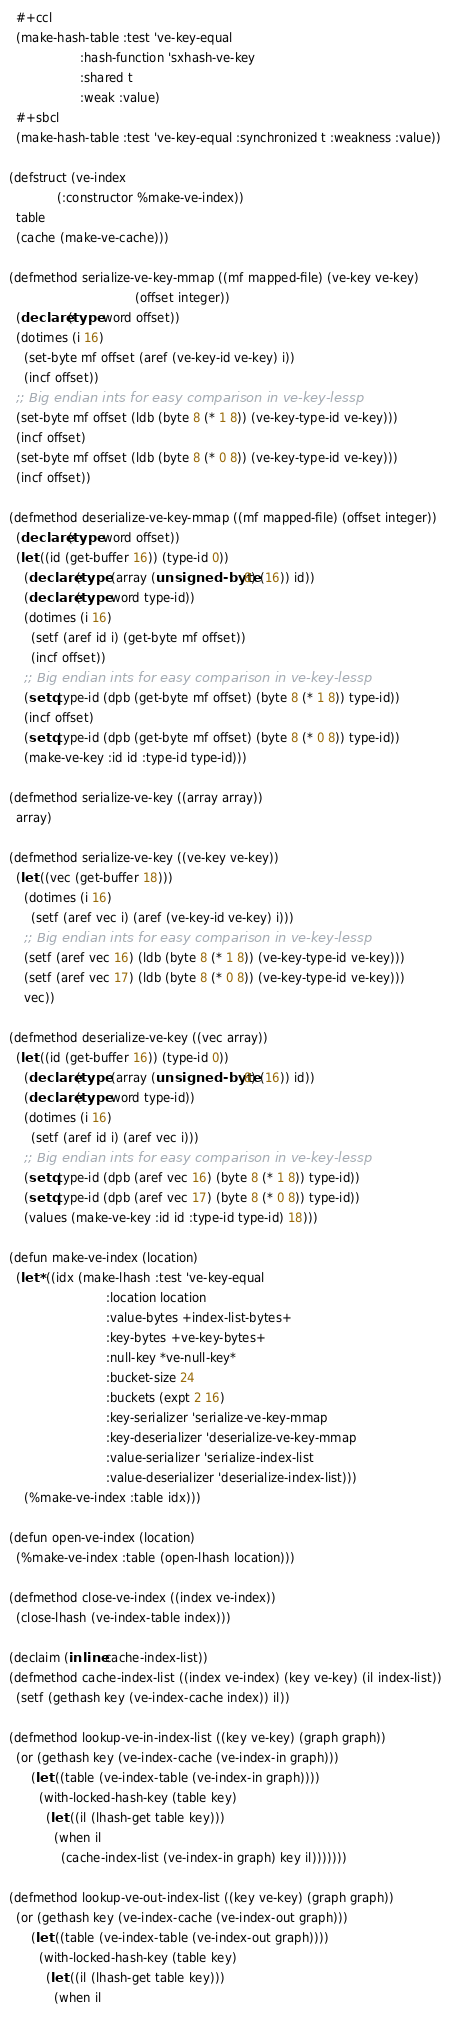<code> <loc_0><loc_0><loc_500><loc_500><_Lisp_>  #+ccl
  (make-hash-table :test 've-key-equal
                   :hash-function 'sxhash-ve-key
                   :shared t
                   :weak :value)
  #+sbcl
  (make-hash-table :test 've-key-equal :synchronized t :weakness :value))

(defstruct (ve-index
             (:constructor %make-ve-index))
  table
  (cache (make-ve-cache)))

(defmethod serialize-ve-key-mmap ((mf mapped-file) (ve-key ve-key)
                                  (offset integer))
  (declare (type word offset))
  (dotimes (i 16)
    (set-byte mf offset (aref (ve-key-id ve-key) i))
    (incf offset))
  ;; Big endian ints for easy comparison in ve-key-lessp
  (set-byte mf offset (ldb (byte 8 (* 1 8)) (ve-key-type-id ve-key)))
  (incf offset)
  (set-byte mf offset (ldb (byte 8 (* 0 8)) (ve-key-type-id ve-key)))
  (incf offset))

(defmethod deserialize-ve-key-mmap ((mf mapped-file) (offset integer))
  (declare (type word offset))
  (let ((id (get-buffer 16)) (type-id 0))
    (declare (type (array (unsigned-byte 8) (16)) id))
    (declare (type word type-id))
    (dotimes (i 16)
      (setf (aref id i) (get-byte mf offset))
      (incf offset))
    ;; Big endian ints for easy comparison in ve-key-lessp
    (setq type-id (dpb (get-byte mf offset) (byte 8 (* 1 8)) type-id))
    (incf offset)
    (setq type-id (dpb (get-byte mf offset) (byte 8 (* 0 8)) type-id))
    (make-ve-key :id id :type-id type-id)))

(defmethod serialize-ve-key ((array array))
  array)

(defmethod serialize-ve-key ((ve-key ve-key))
  (let ((vec (get-buffer 18)))
    (dotimes (i 16)
      (setf (aref vec i) (aref (ve-key-id ve-key) i)))
    ;; Big endian ints for easy comparison in ve-key-lessp
    (setf (aref vec 16) (ldb (byte 8 (* 1 8)) (ve-key-type-id ve-key)))
    (setf (aref vec 17) (ldb (byte 8 (* 0 8)) (ve-key-type-id ve-key)))
    vec))

(defmethod deserialize-ve-key ((vec array))
  (let ((id (get-buffer 16)) (type-id 0))
    (declare (type (array (unsigned-byte 8) (16)) id))
    (declare (type word type-id))
    (dotimes (i 16)
      (setf (aref id i) (aref vec i)))
    ;; Big endian ints for easy comparison in ve-key-lessp
    (setq type-id (dpb (aref vec 16) (byte 8 (* 1 8)) type-id))
    (setq type-id (dpb (aref vec 17) (byte 8 (* 0 8)) type-id))
    (values (make-ve-key :id id :type-id type-id) 18)))

(defun make-ve-index (location)
  (let* ((idx (make-lhash :test 've-key-equal
                          :location location
                          :value-bytes +index-list-bytes+
                          :key-bytes +ve-key-bytes+
                          :null-key *ve-null-key*
                          :bucket-size 24
                          :buckets (expt 2 16)
                          :key-serializer 'serialize-ve-key-mmap
                          :key-deserializer 'deserialize-ve-key-mmap
                          :value-serializer 'serialize-index-list
                          :value-deserializer 'deserialize-index-list)))
    (%make-ve-index :table idx)))

(defun open-ve-index (location)
  (%make-ve-index :table (open-lhash location)))

(defmethod close-ve-index ((index ve-index))
  (close-lhash (ve-index-table index)))

(declaim (inline cache-index-list))
(defmethod cache-index-list ((index ve-index) (key ve-key) (il index-list))
  (setf (gethash key (ve-index-cache index)) il))

(defmethod lookup-ve-in-index-list ((key ve-key) (graph graph))
  (or (gethash key (ve-index-cache (ve-index-in graph)))
      (let ((table (ve-index-table (ve-index-in graph))))
        (with-locked-hash-key (table key)
          (let ((il (lhash-get table key)))
            (when il
              (cache-index-list (ve-index-in graph) key il)))))))

(defmethod lookup-ve-out-index-list ((key ve-key) (graph graph))
  (or (gethash key (ve-index-cache (ve-index-out graph)))
      (let ((table (ve-index-table (ve-index-out graph))))
        (with-locked-hash-key (table key)
          (let ((il (lhash-get table key)))
            (when il</code> 